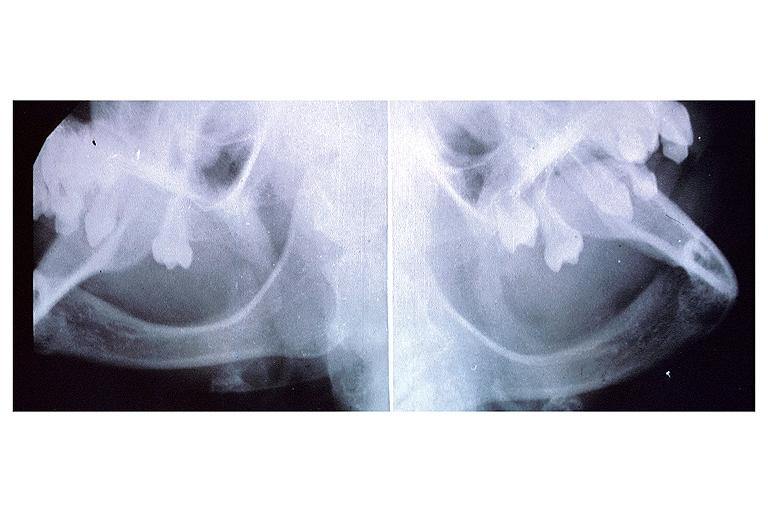does this image show anhidrotic ectodermal dysplasia?
Answer the question using a single word or phrase. Yes 